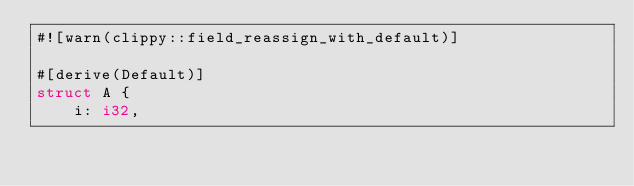Convert code to text. <code><loc_0><loc_0><loc_500><loc_500><_Rust_>#![warn(clippy::field_reassign_with_default)]

#[derive(Default)]
struct A {
    i: i32,</code> 